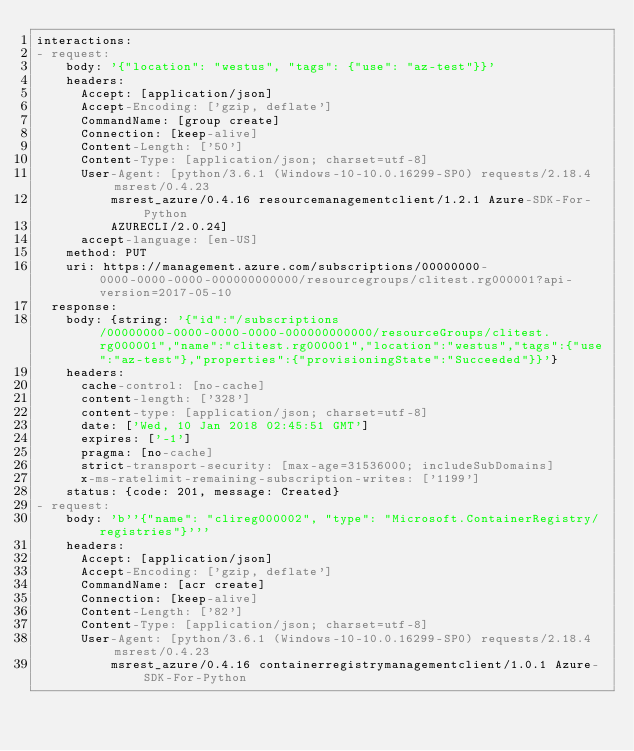<code> <loc_0><loc_0><loc_500><loc_500><_YAML_>interactions:
- request:
    body: '{"location": "westus", "tags": {"use": "az-test"}}'
    headers:
      Accept: [application/json]
      Accept-Encoding: ['gzip, deflate']
      CommandName: [group create]
      Connection: [keep-alive]
      Content-Length: ['50']
      Content-Type: [application/json; charset=utf-8]
      User-Agent: [python/3.6.1 (Windows-10-10.0.16299-SP0) requests/2.18.4 msrest/0.4.23
          msrest_azure/0.4.16 resourcemanagementclient/1.2.1 Azure-SDK-For-Python
          AZURECLI/2.0.24]
      accept-language: [en-US]
    method: PUT
    uri: https://management.azure.com/subscriptions/00000000-0000-0000-0000-000000000000/resourcegroups/clitest.rg000001?api-version=2017-05-10
  response:
    body: {string: '{"id":"/subscriptions/00000000-0000-0000-0000-000000000000/resourceGroups/clitest.rg000001","name":"clitest.rg000001","location":"westus","tags":{"use":"az-test"},"properties":{"provisioningState":"Succeeded"}}'}
    headers:
      cache-control: [no-cache]
      content-length: ['328']
      content-type: [application/json; charset=utf-8]
      date: ['Wed, 10 Jan 2018 02:45:51 GMT']
      expires: ['-1']
      pragma: [no-cache]
      strict-transport-security: [max-age=31536000; includeSubDomains]
      x-ms-ratelimit-remaining-subscription-writes: ['1199']
    status: {code: 201, message: Created}
- request:
    body: 'b''{"name": "clireg000002", "type": "Microsoft.ContainerRegistry/registries"}'''
    headers:
      Accept: [application/json]
      Accept-Encoding: ['gzip, deflate']
      CommandName: [acr create]
      Connection: [keep-alive]
      Content-Length: ['82']
      Content-Type: [application/json; charset=utf-8]
      User-Agent: [python/3.6.1 (Windows-10-10.0.16299-SP0) requests/2.18.4 msrest/0.4.23
          msrest_azure/0.4.16 containerregistrymanagementclient/1.0.1 Azure-SDK-For-Python</code> 